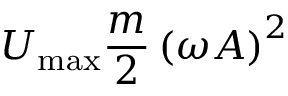<formula> <loc_0><loc_0><loc_500><loc_500>U _ { \max } { \frac { m } { 2 } } \left ( \omega A \right ) ^ { 2 }</formula> 